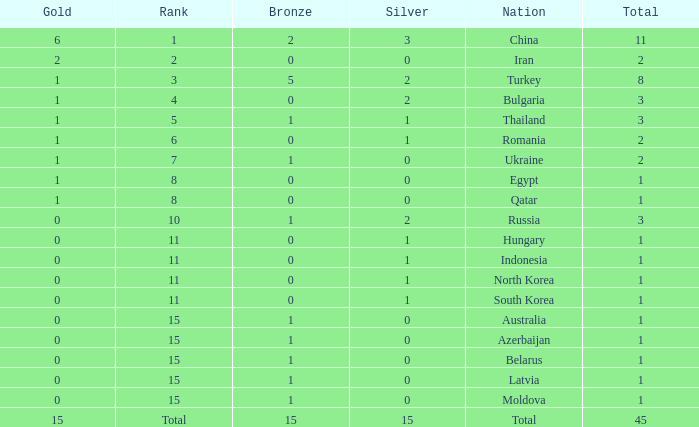Wha is the average number of bronze of hungary, which has less than 1 silver? None. 